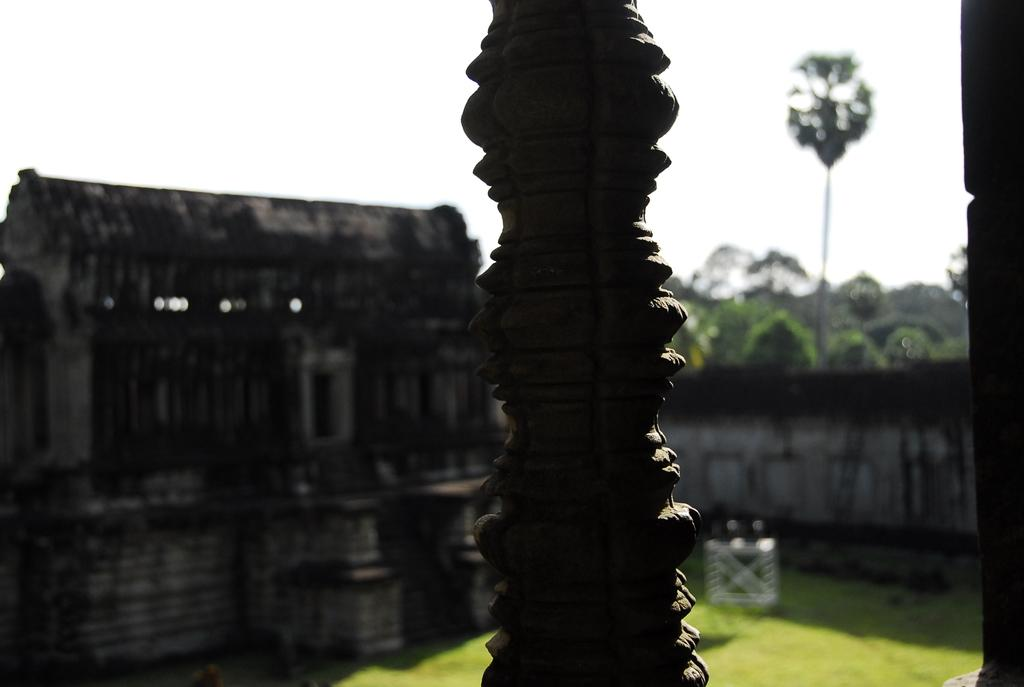What is the main structure or object in the image? There is a monument in the image. What type of architectural elements can be seen in the image? There are walls in the image. What type of natural elements can be seen in the image? There are trees in the image. What is visible in the background of the image? The sky is visible in the image. What type of dinner is being served on the ship in the image? There is no ship or dinner present in the image; it features a monument, walls, trees, and the sky. 